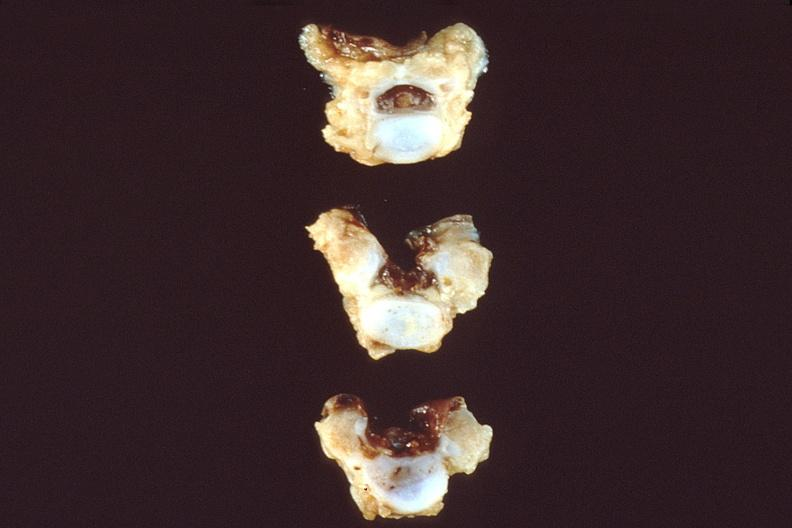what does this image show?
Answer the question using a single word or phrase. Neural tube defect 